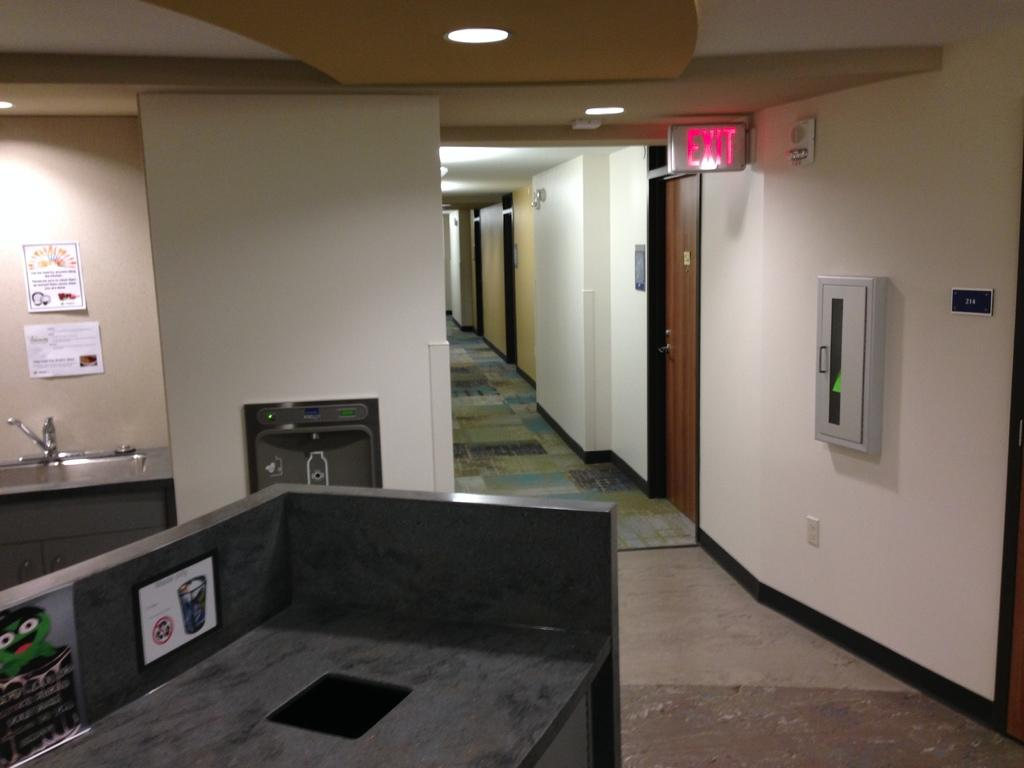<image>
Summarize the visual content of the image. A picture of an office building with a sink and an exit sign in the hallway. 